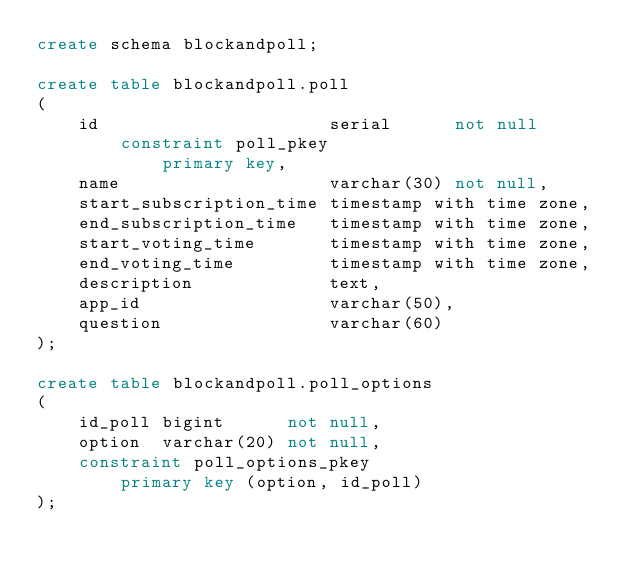<code> <loc_0><loc_0><loc_500><loc_500><_SQL_>create schema blockandpoll;

create table blockandpoll.poll
(
    id                      serial      not null
        constraint poll_pkey
            primary key,
    name                    varchar(30) not null,
    start_subscription_time timestamp with time zone,
    end_subscription_time   timestamp with time zone,
    start_voting_time       timestamp with time zone,
    end_voting_time         timestamp with time zone,
    description             text,
    app_id                  varchar(50),
    question                varchar(60)
);

create table blockandpoll.poll_options
(
    id_poll bigint      not null,
    option  varchar(20) not null,
    constraint poll_options_pkey
        primary key (option, id_poll)
);</code> 